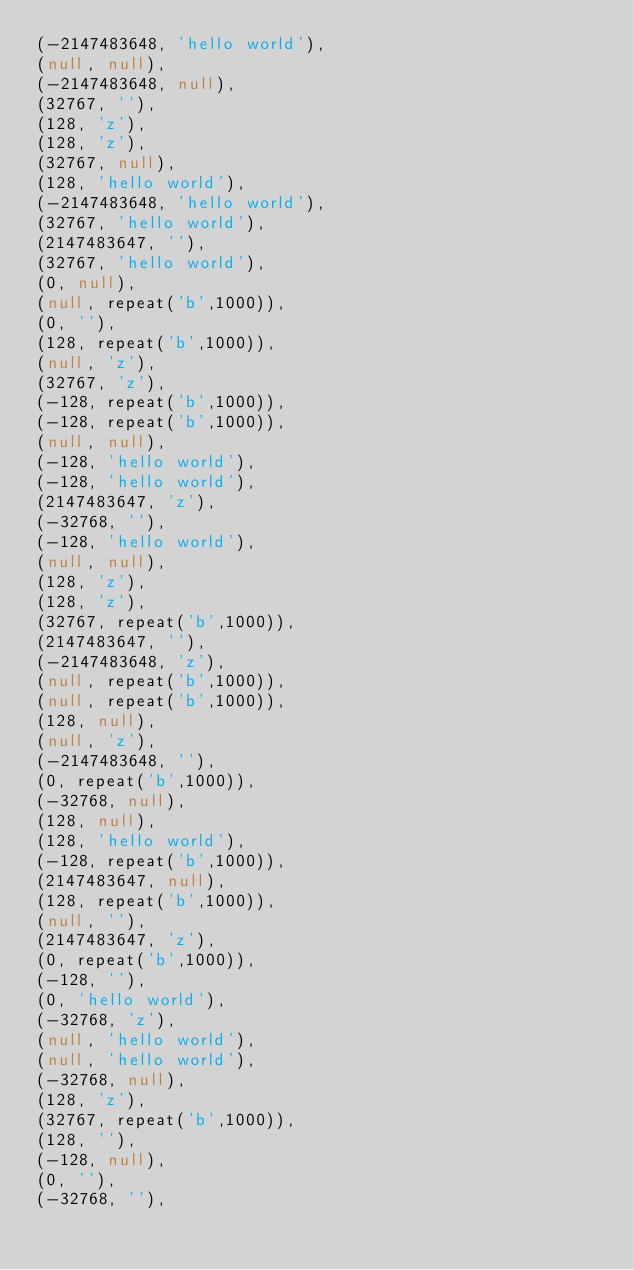Convert code to text. <code><loc_0><loc_0><loc_500><loc_500><_SQL_>(-2147483648, 'hello world'),
(null, null),
(-2147483648, null),
(32767, ''),
(128, 'z'),
(128, 'z'),
(32767, null),
(128, 'hello world'),
(-2147483648, 'hello world'),
(32767, 'hello world'),
(2147483647, ''),
(32767, 'hello world'),
(0, null),
(null, repeat('b',1000)),
(0, ''),
(128, repeat('b',1000)),
(null, 'z'),
(32767, 'z'),
(-128, repeat('b',1000)),
(-128, repeat('b',1000)),
(null, null),
(-128, 'hello world'),
(-128, 'hello world'),
(2147483647, 'z'),
(-32768, ''),
(-128, 'hello world'),
(null, null),
(128, 'z'),
(128, 'z'),
(32767, repeat('b',1000)),
(2147483647, ''),
(-2147483648, 'z'),
(null, repeat('b',1000)),
(null, repeat('b',1000)),
(128, null),
(null, 'z'),
(-2147483648, ''),
(0, repeat('b',1000)),
(-32768, null),
(128, null),
(128, 'hello world'),
(-128, repeat('b',1000)),
(2147483647, null),
(128, repeat('b',1000)),
(null, ''),
(2147483647, 'z'),
(0, repeat('b',1000)),
(-128, ''),
(0, 'hello world'),
(-32768, 'z'),
(null, 'hello world'),
(null, 'hello world'),
(-32768, null),
(128, 'z'),
(32767, repeat('b',1000)),
(128, ''),
(-128, null),
(0, ''),
(-32768, ''),</code> 